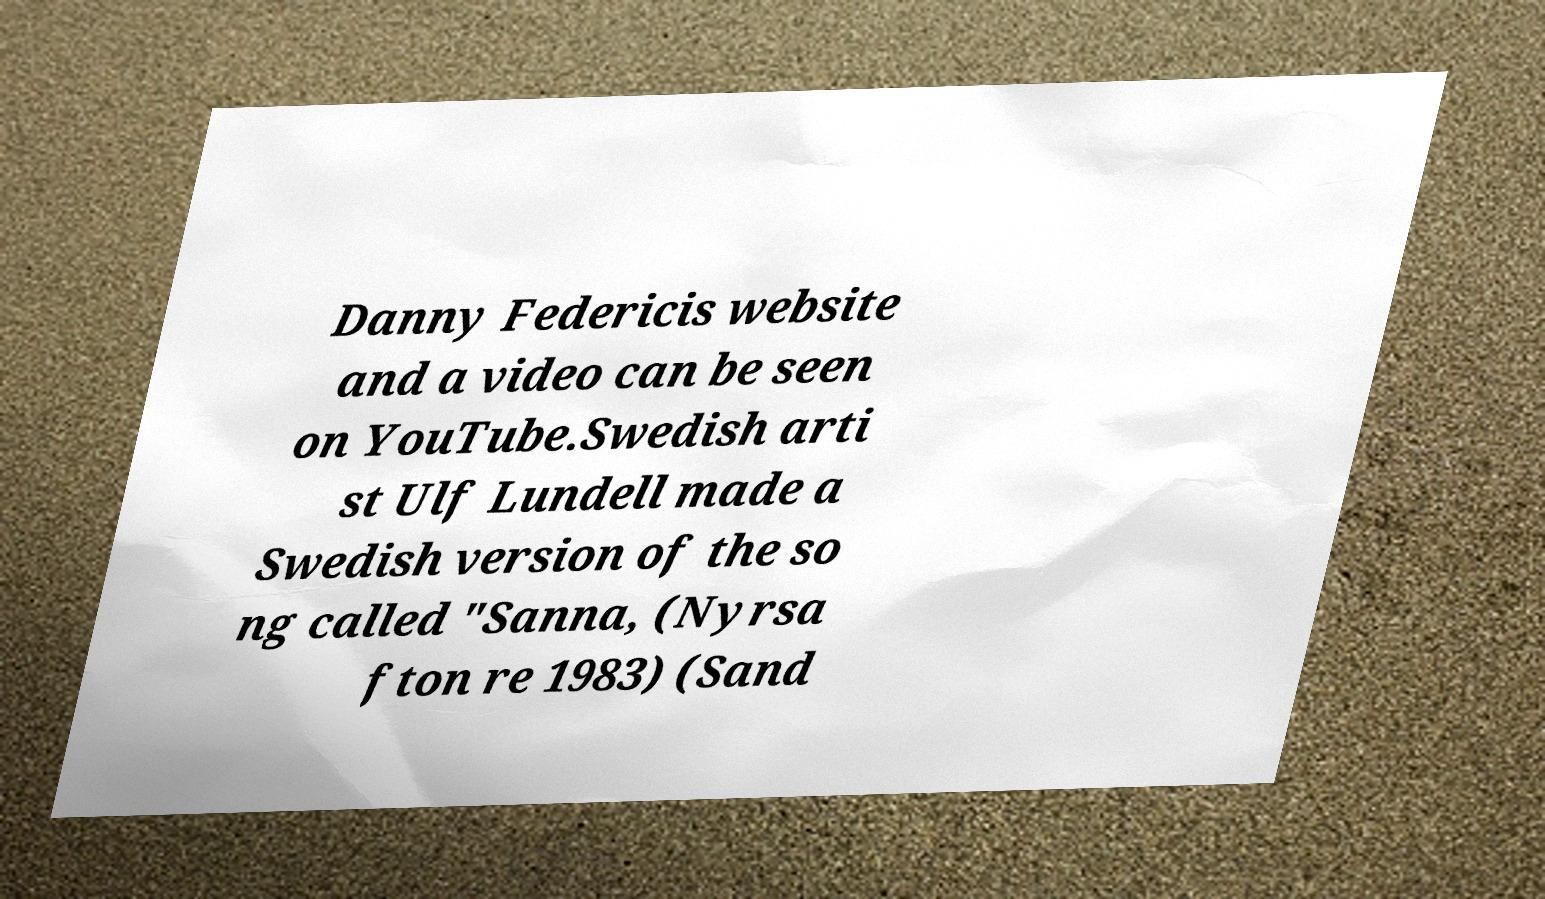Can you accurately transcribe the text from the provided image for me? Danny Federicis website and a video can be seen on YouTube.Swedish arti st Ulf Lundell made a Swedish version of the so ng called "Sanna, (Nyrsa fton re 1983) (Sand 